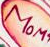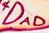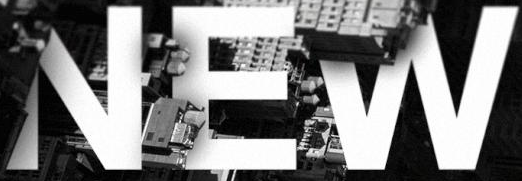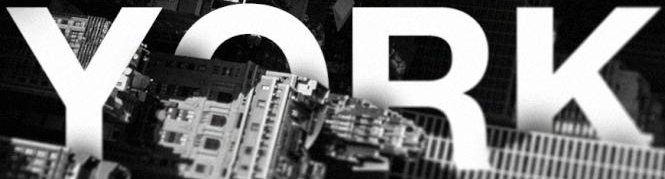Transcribe the words shown in these images in order, separated by a semicolon. MOM; DAD; NEW; YORK 